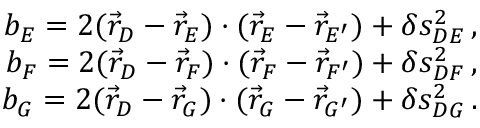<formula> <loc_0><loc_0><loc_500><loc_500>\begin{array} { r } { b _ { E } = 2 ( \vec { r } _ { D } - \vec { r } _ { E } ) \cdot ( \vec { r } _ { E } - \vec { r } _ { E ^ { \prime } } ) + \delta s _ { D E } ^ { 2 } \, , } \\ { b _ { F } = 2 ( \vec { r } _ { D } - \vec { r } _ { F } ) \cdot ( \vec { r } _ { F } - \vec { r } _ { F ^ { \prime } } ) + \delta s _ { D F } ^ { 2 } \, , } \\ { b _ { G } = 2 ( \vec { r } _ { D } - \vec { r } _ { G } ) \cdot ( \vec { r } _ { G } - \vec { r } _ { G ^ { \prime } } ) + \delta s _ { D G } ^ { 2 } \, . } \end{array}</formula> 